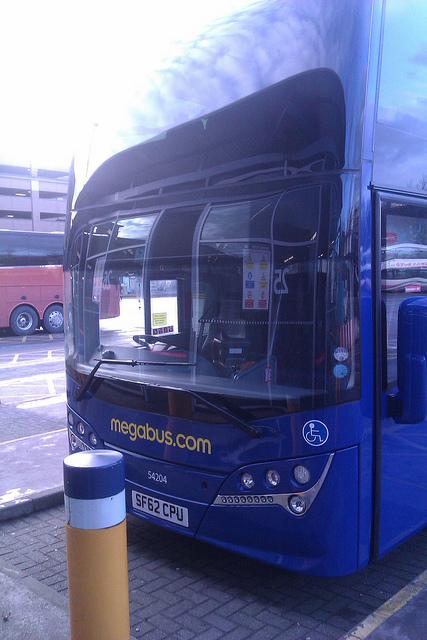What does the blue decal indicate?
Quick response, please. Handicap accessible. Is there anyone in the driver's seat?
Concise answer only. No. What color is the bus?
Answer briefly. Blue. 